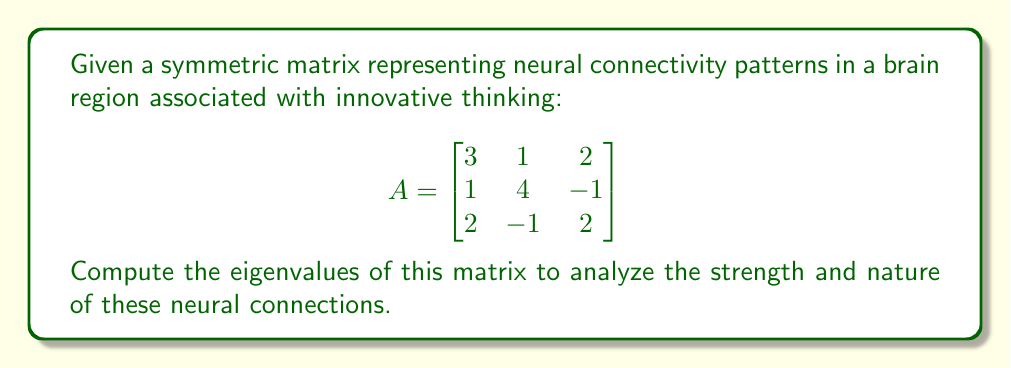Help me with this question. To find the eigenvalues of the symmetric matrix A, we follow these steps:

1) The eigenvalues λ are the solutions to the characteristic equation:
   $$det(A - λI) = 0$$
   where I is the 3x3 identity matrix.

2) Expand the determinant:
   $$det\begin{bmatrix}
   3-λ & 1 & 2 \\
   1 & 4-λ & -1 \\
   2 & -1 & 2-λ
   \end{bmatrix} = 0$$

3) Calculate the determinant:
   $$(3-λ)[(4-λ)(2-λ) - (-1)(-1)] - 1[1(2-λ) - 2(-1)] + 2[1(-1) - (4-λ)(2)] = 0$$

4) Simplify:
   $$(3-λ)(8-6λ+λ^2-1) - (2-λ-2) + 2(-1-4+2λ) = 0$$
   $$(3-λ)(7-6λ+λ^2) - λ - 10 + 4λ = 0$$
   $$21-18λ+3λ^2-7λ+6λ^2-λ^3 - λ - 10 + 4λ = 0$$
   $$-λ^3 + 9λ^2 - 22λ + 11 = 0$$

5) This is a cubic equation. We can factor out (λ-1):
   $$(λ-1)(-λ^2 + 8λ - 11) = 0$$

6) Using the quadratic formula for $-λ^2 + 8λ - 11 = 0$:
   $$λ = \frac{-8 \pm \sqrt{64 - 44}}{-2} = \frac{-8 \pm \sqrt{20}}{-2} = 4 \pm \sqrt{5}$$

Therefore, the eigenvalues are: λ₁ = 1, λ₂ = 4 + √5, λ₃ = 4 - √5
Answer: 1, 4 + √5, 4 - √5 